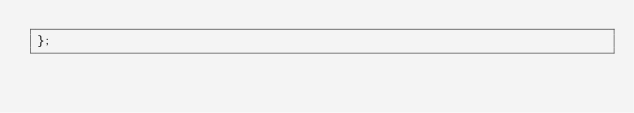Convert code to text. <code><loc_0><loc_0><loc_500><loc_500><_TypeScript_>};


</code> 